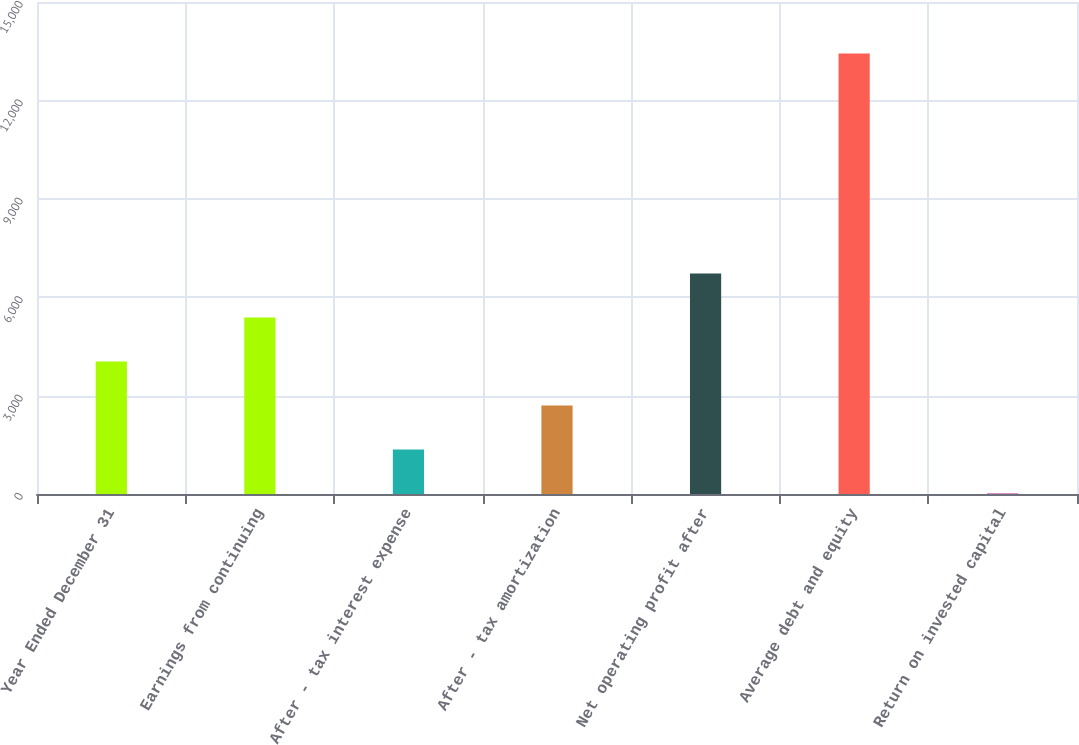Convert chart. <chart><loc_0><loc_0><loc_500><loc_500><bar_chart><fcel>Year Ended December 31<fcel>Earnings from continuing<fcel>After - tax interest expense<fcel>After - tax amortization<fcel>Net operating profit after<fcel>Average debt and equity<fcel>Return on invested capital<nl><fcel>4040.83<fcel>5382.14<fcel>1358.21<fcel>2699.52<fcel>6723.45<fcel>13430<fcel>16.9<nl></chart> 